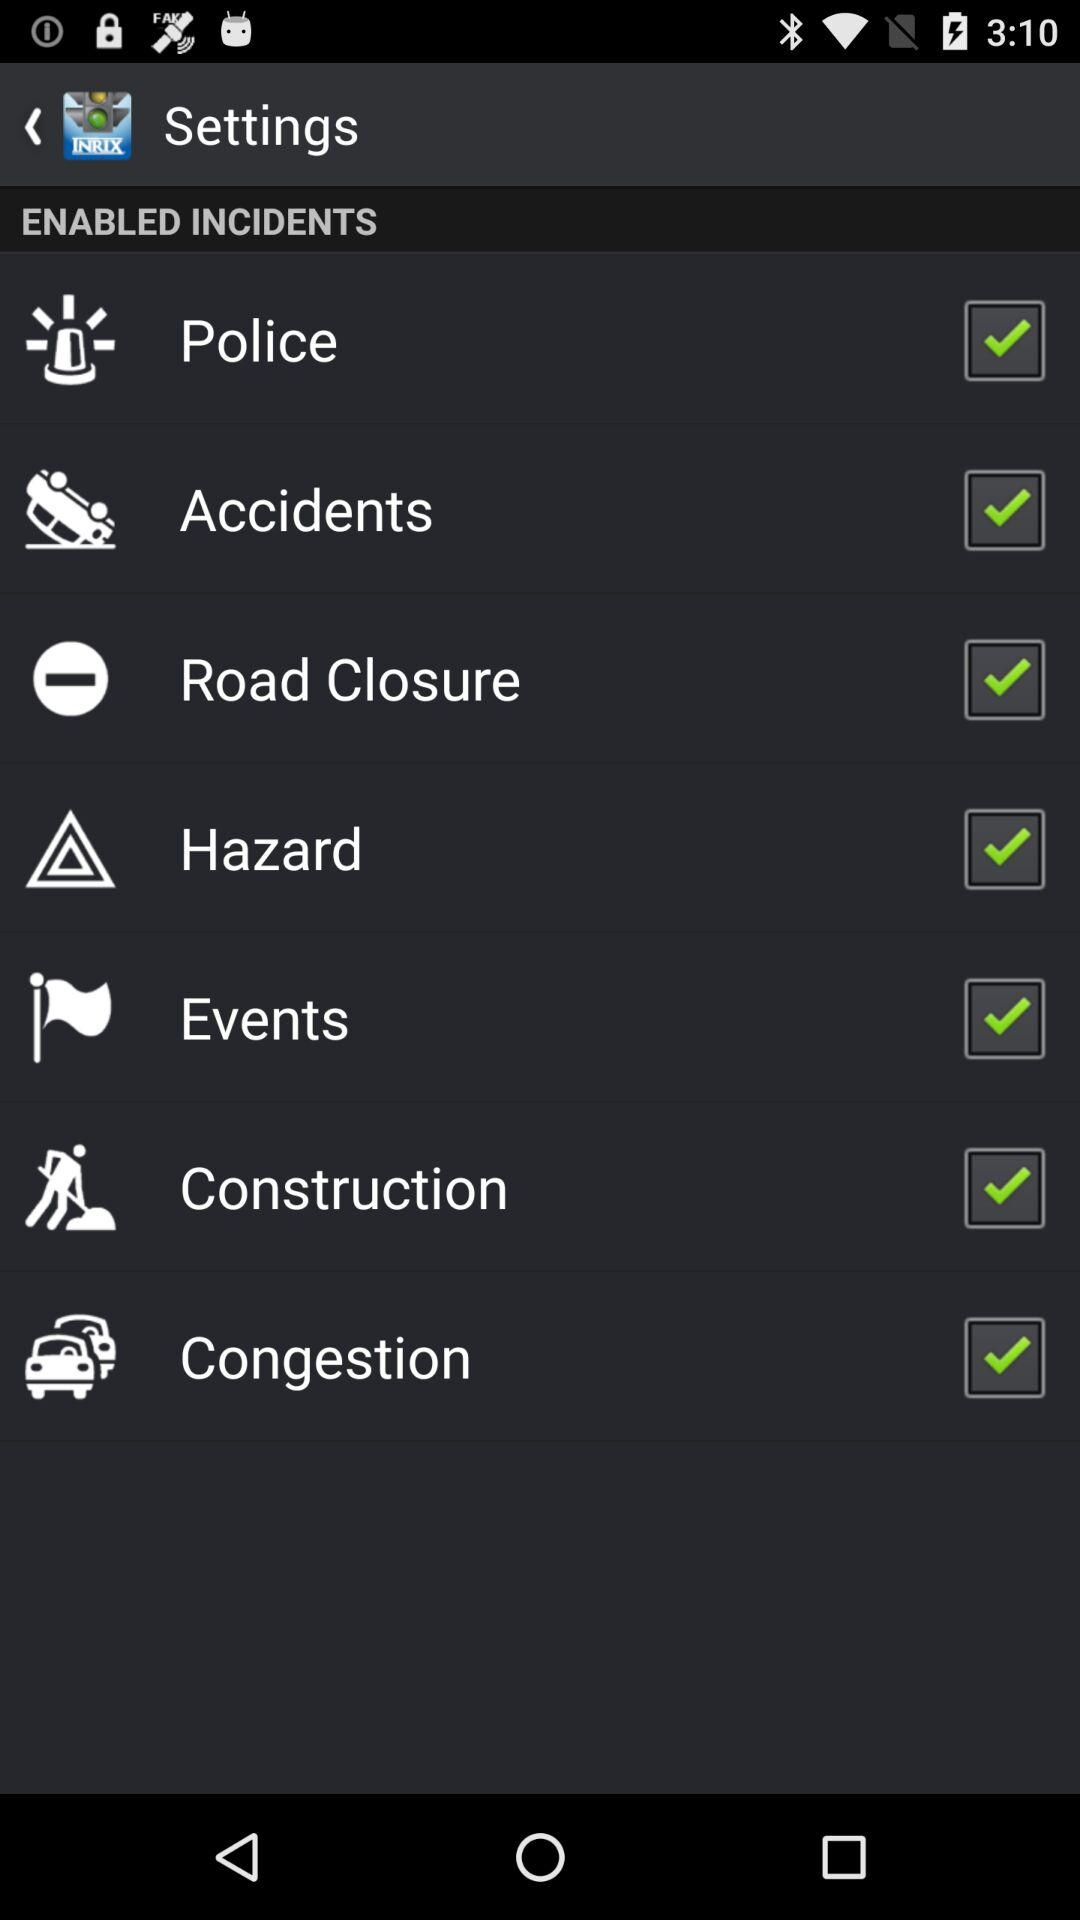What is the status of "Road Closure"? The status of "Road Closure" is "on". 